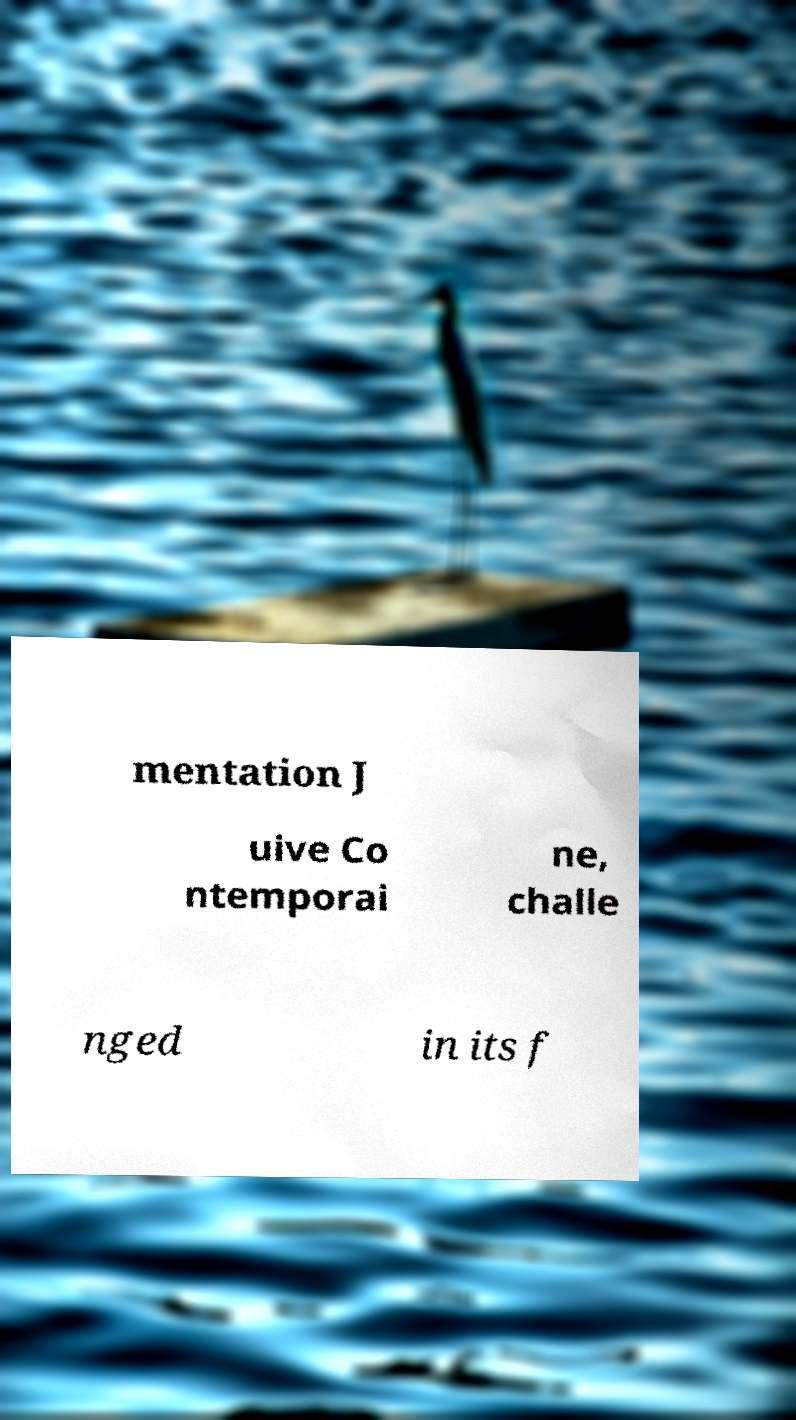Could you assist in decoding the text presented in this image and type it out clearly? mentation J uive Co ntemporai ne, challe nged in its f 